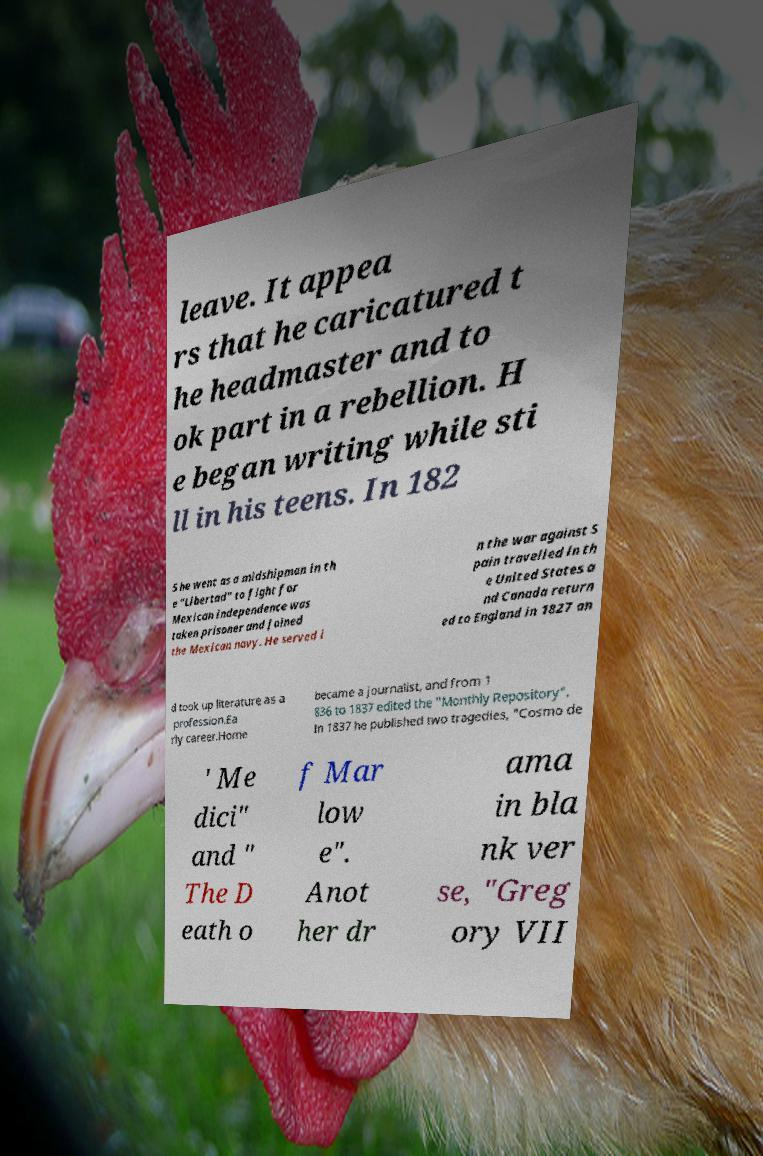Can you accurately transcribe the text from the provided image for me? leave. It appea rs that he caricatured t he headmaster and to ok part in a rebellion. H e began writing while sti ll in his teens. In 182 5 he went as a midshipman in th e "Libertad" to fight for Mexican independence was taken prisoner and joined the Mexican navy. He served i n the war against S pain travelled in th e United States a nd Canada return ed to England in 1827 an d took up literature as a profession.Ea rly career.Horne became a journalist, and from 1 836 to 1837 edited the "Monthly Repository". In 1837 he published two tragedies, "Cosmo de ' Me dici" and " The D eath o f Mar low e". Anot her dr ama in bla nk ver se, "Greg ory VII 